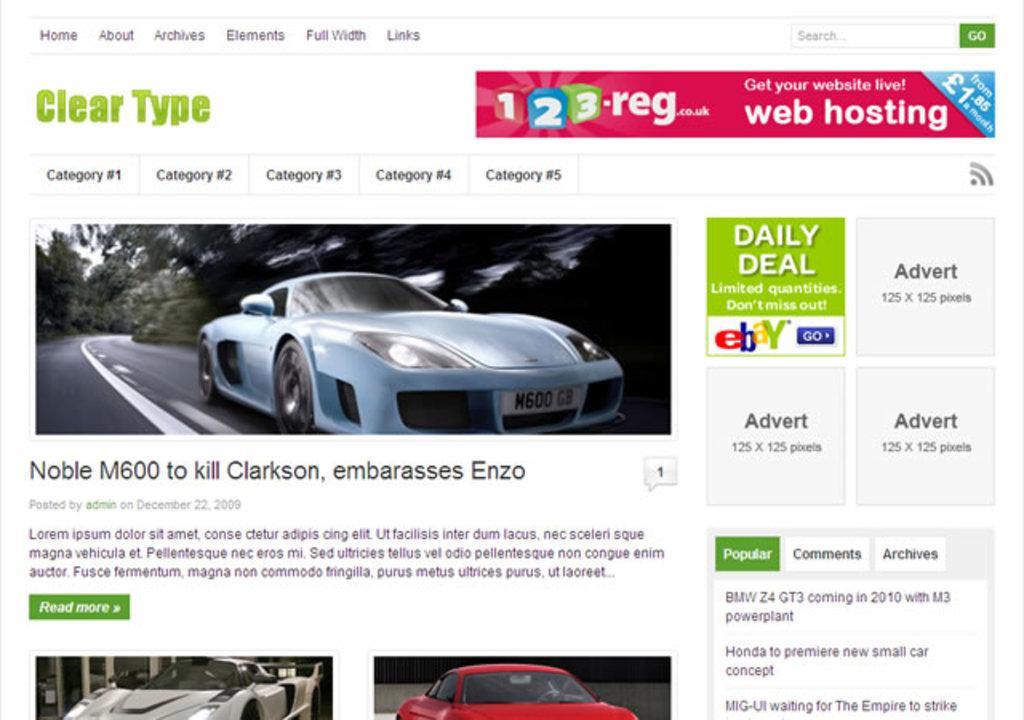In one or two sentences, can you explain what this image depicts? The picture consists of a website or a screenshot of a desktop. In this picture we can see text, cars and numbers. 